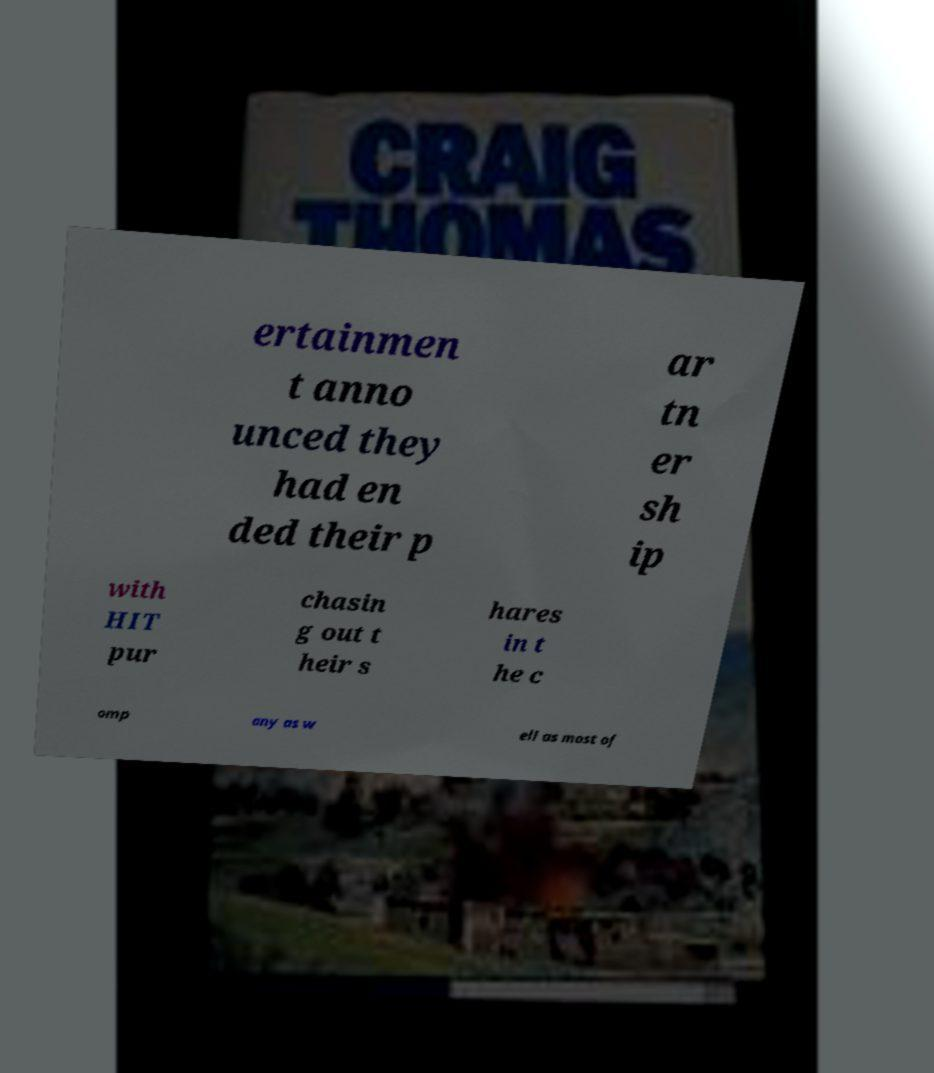Please read and relay the text visible in this image. What does it say? ertainmen t anno unced they had en ded their p ar tn er sh ip with HIT pur chasin g out t heir s hares in t he c omp any as w ell as most of 